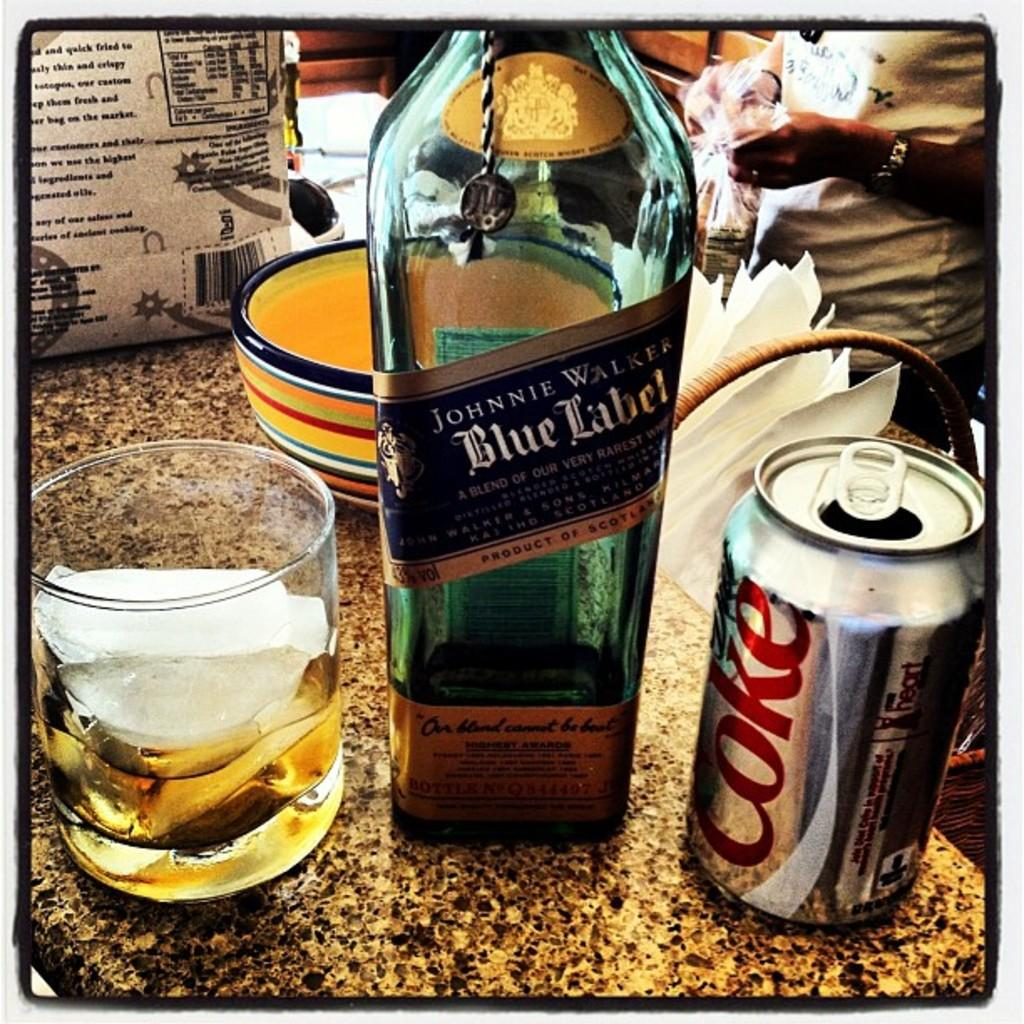Provide a one-sentence caption for the provided image. Johnnie Walker Blue Label alongside a glass of the whisky mixed with some Coca Cola. 